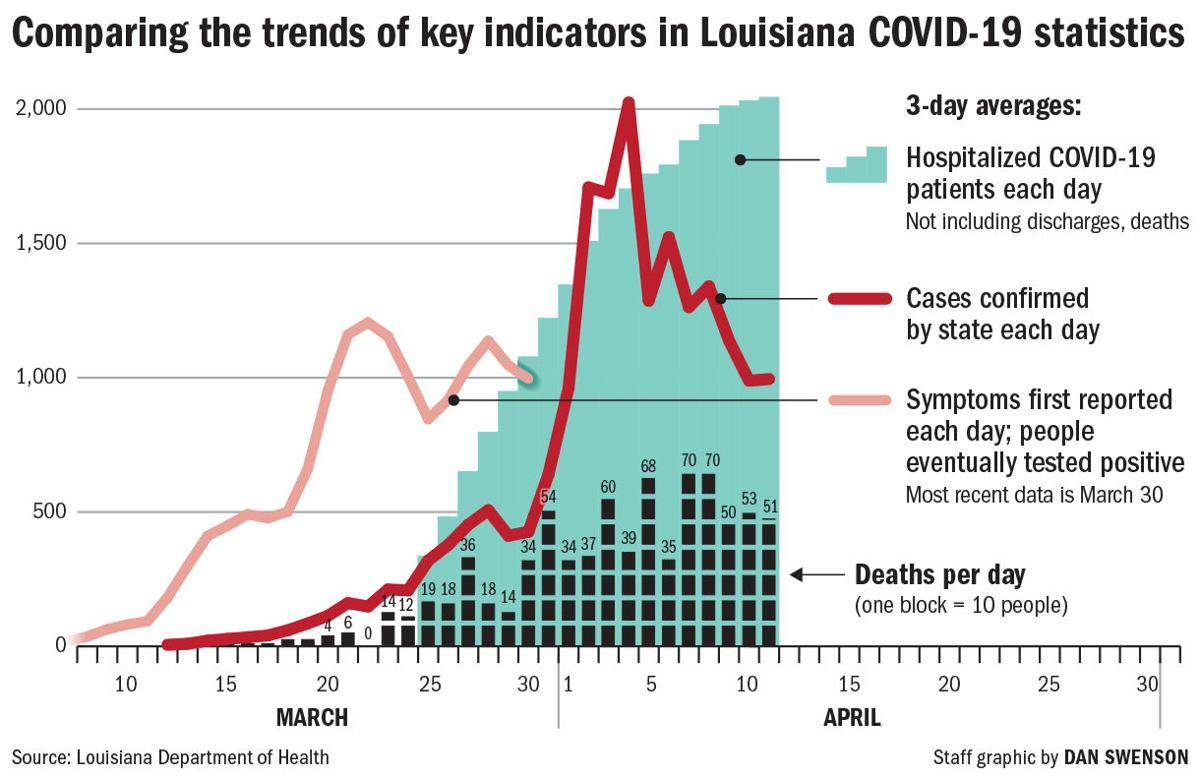Indicate a few pertinent items in this graphic. In how many people does two blocks equal 20? The color used to represent cases confirmed by the state each day is red. The number of people required to equal three blocks is 30. 